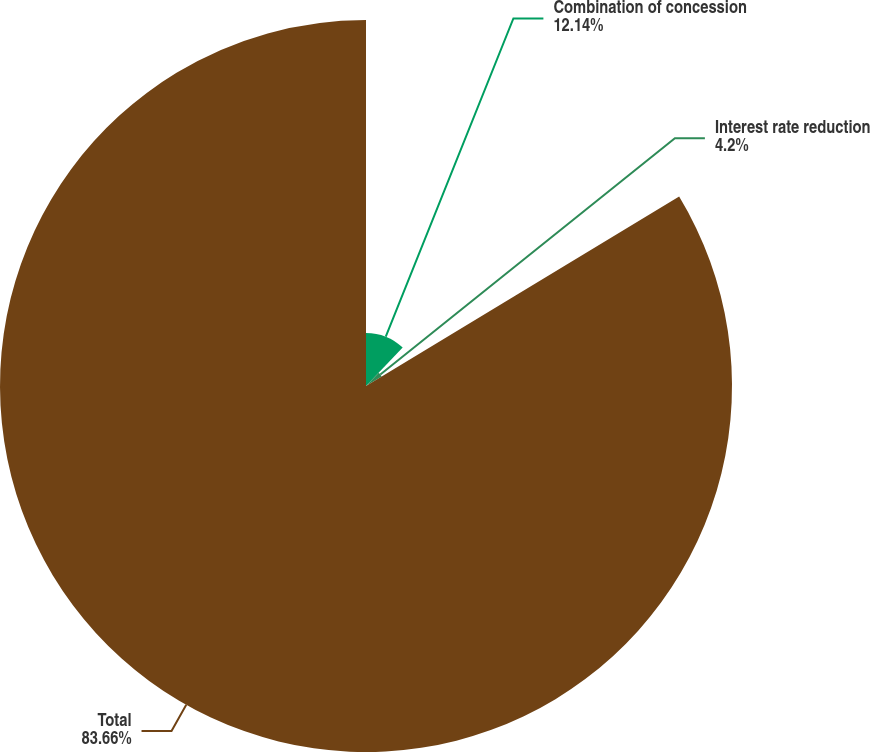Convert chart. <chart><loc_0><loc_0><loc_500><loc_500><pie_chart><fcel>Combination of concession<fcel>Interest rate reduction<fcel>Total<nl><fcel>12.14%<fcel>4.2%<fcel>83.66%<nl></chart> 